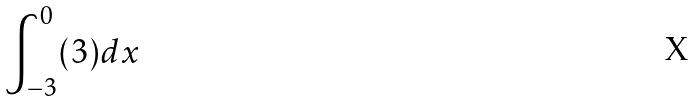Convert formula to latex. <formula><loc_0><loc_0><loc_500><loc_500>\int _ { - 3 } ^ { 0 } ( 3 ) d x</formula> 